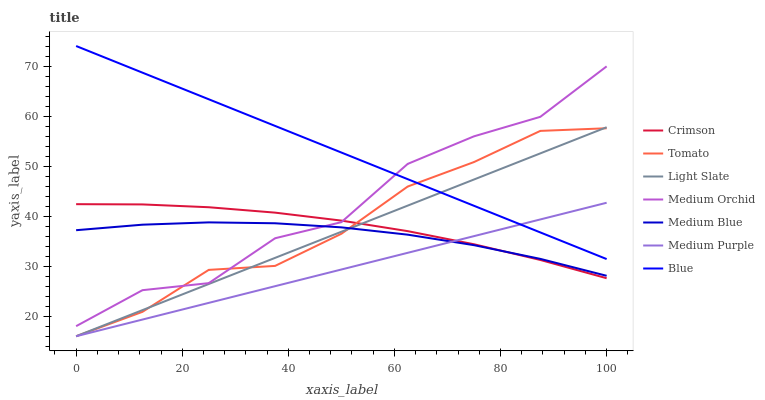Does Medium Purple have the minimum area under the curve?
Answer yes or no. Yes. Does Blue have the maximum area under the curve?
Answer yes or no. Yes. Does Light Slate have the minimum area under the curve?
Answer yes or no. No. Does Light Slate have the maximum area under the curve?
Answer yes or no. No. Is Medium Purple the smoothest?
Answer yes or no. Yes. Is Medium Orchid the roughest?
Answer yes or no. Yes. Is Blue the smoothest?
Answer yes or no. No. Is Blue the roughest?
Answer yes or no. No. Does Tomato have the lowest value?
Answer yes or no. Yes. Does Blue have the lowest value?
Answer yes or no. No. Does Blue have the highest value?
Answer yes or no. Yes. Does Light Slate have the highest value?
Answer yes or no. No. Is Crimson less than Blue?
Answer yes or no. Yes. Is Medium Orchid greater than Medium Purple?
Answer yes or no. Yes. Does Crimson intersect Medium Blue?
Answer yes or no. Yes. Is Crimson less than Medium Blue?
Answer yes or no. No. Is Crimson greater than Medium Blue?
Answer yes or no. No. Does Crimson intersect Blue?
Answer yes or no. No. 